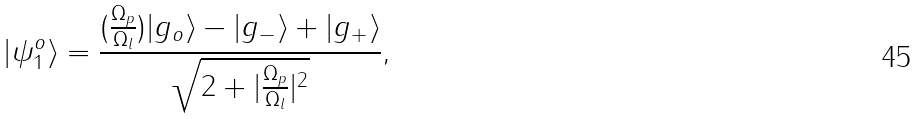Convert formula to latex. <formula><loc_0><loc_0><loc_500><loc_500>| \psi _ { 1 } ^ { o } \rangle = \frac { ( \frac { \Omega _ { p } } { \Omega _ { l } } ) | g _ { o } \rangle - | g _ { - } \rangle + | g _ { + } \rangle } { \sqrt { 2 + | \frac { \Omega _ { p } } { \Omega _ { l } } | ^ { 2 } } } ,</formula> 